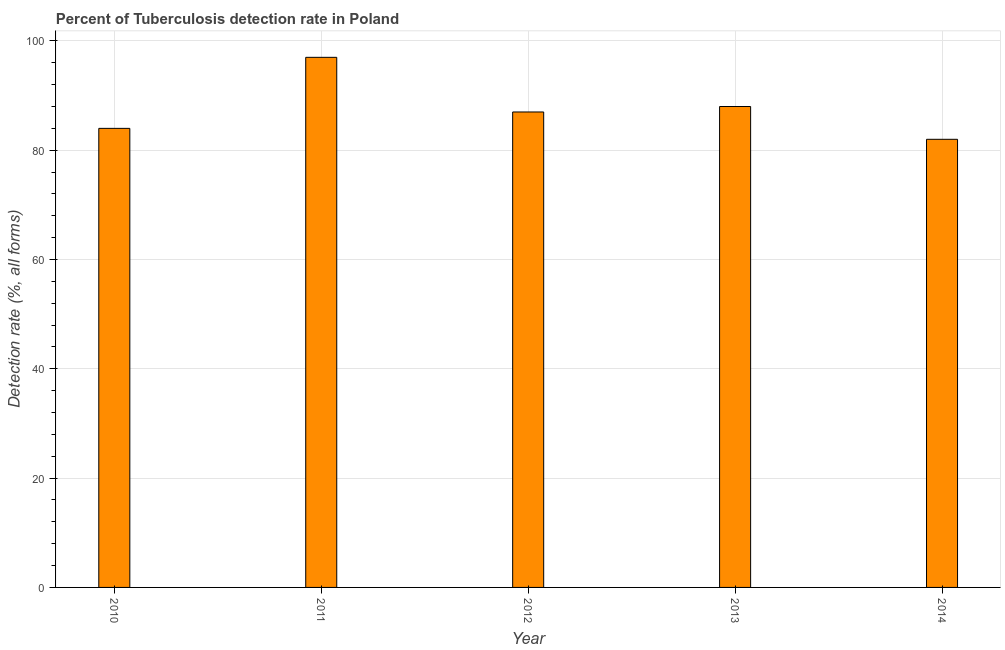Does the graph contain grids?
Offer a very short reply. Yes. What is the title of the graph?
Provide a succinct answer. Percent of Tuberculosis detection rate in Poland. What is the label or title of the X-axis?
Provide a short and direct response. Year. What is the label or title of the Y-axis?
Provide a short and direct response. Detection rate (%, all forms). What is the detection rate of tuberculosis in 2011?
Offer a very short reply. 97. Across all years, what is the maximum detection rate of tuberculosis?
Provide a succinct answer. 97. Across all years, what is the minimum detection rate of tuberculosis?
Make the answer very short. 82. What is the sum of the detection rate of tuberculosis?
Your answer should be very brief. 438. What is the average detection rate of tuberculosis per year?
Make the answer very short. 87. Do a majority of the years between 2011 and 2013 (inclusive) have detection rate of tuberculosis greater than 96 %?
Provide a short and direct response. No. What is the ratio of the detection rate of tuberculosis in 2010 to that in 2011?
Ensure brevity in your answer.  0.87. Is the detection rate of tuberculosis in 2010 less than that in 2012?
Provide a short and direct response. Yes. Is the difference between the detection rate of tuberculosis in 2012 and 2014 greater than the difference between any two years?
Give a very brief answer. No. In how many years, is the detection rate of tuberculosis greater than the average detection rate of tuberculosis taken over all years?
Your answer should be very brief. 2. What is the difference between two consecutive major ticks on the Y-axis?
Keep it short and to the point. 20. Are the values on the major ticks of Y-axis written in scientific E-notation?
Offer a very short reply. No. What is the Detection rate (%, all forms) in 2011?
Your answer should be compact. 97. What is the Detection rate (%, all forms) in 2012?
Ensure brevity in your answer.  87. What is the difference between the Detection rate (%, all forms) in 2010 and 2013?
Your answer should be compact. -4. What is the difference between the Detection rate (%, all forms) in 2012 and 2014?
Keep it short and to the point. 5. What is the difference between the Detection rate (%, all forms) in 2013 and 2014?
Give a very brief answer. 6. What is the ratio of the Detection rate (%, all forms) in 2010 to that in 2011?
Offer a terse response. 0.87. What is the ratio of the Detection rate (%, all forms) in 2010 to that in 2012?
Your answer should be very brief. 0.97. What is the ratio of the Detection rate (%, all forms) in 2010 to that in 2013?
Your response must be concise. 0.95. What is the ratio of the Detection rate (%, all forms) in 2011 to that in 2012?
Provide a succinct answer. 1.11. What is the ratio of the Detection rate (%, all forms) in 2011 to that in 2013?
Keep it short and to the point. 1.1. What is the ratio of the Detection rate (%, all forms) in 2011 to that in 2014?
Ensure brevity in your answer.  1.18. What is the ratio of the Detection rate (%, all forms) in 2012 to that in 2013?
Offer a terse response. 0.99. What is the ratio of the Detection rate (%, all forms) in 2012 to that in 2014?
Your answer should be very brief. 1.06. What is the ratio of the Detection rate (%, all forms) in 2013 to that in 2014?
Provide a short and direct response. 1.07. 